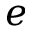<formula> <loc_0><loc_0><loc_500><loc_500>e</formula> 